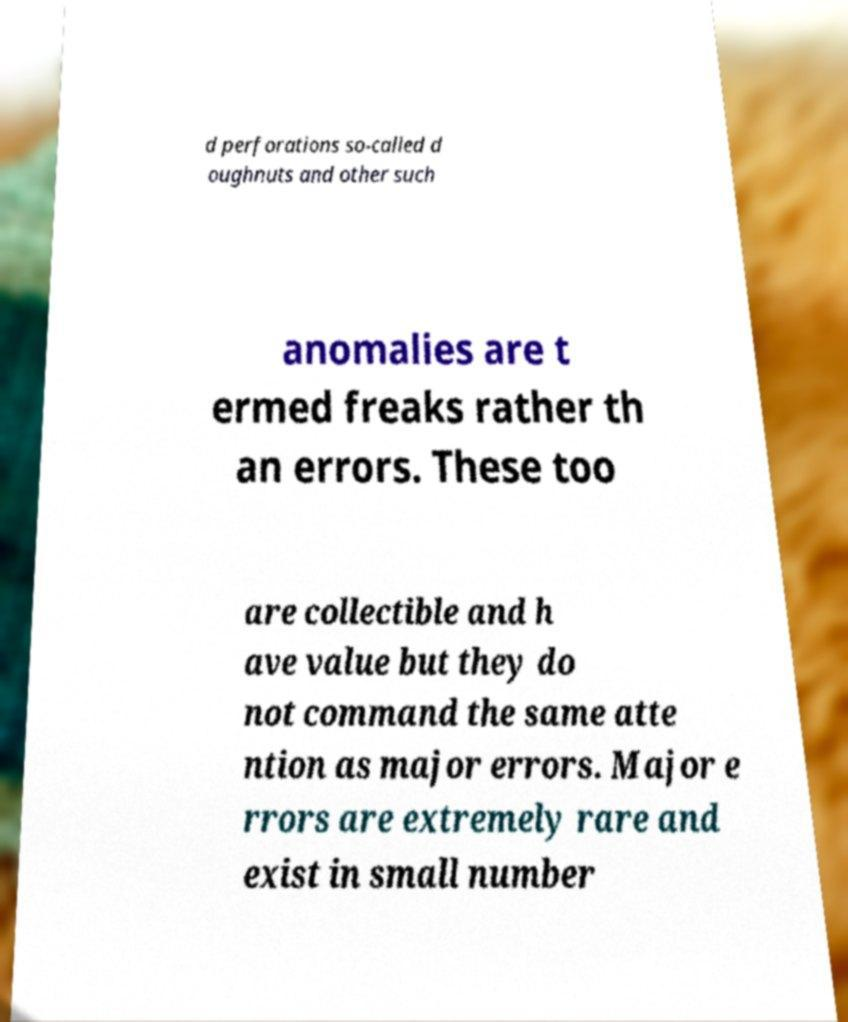Please identify and transcribe the text found in this image. d perforations so-called d oughnuts and other such anomalies are t ermed freaks rather th an errors. These too are collectible and h ave value but they do not command the same atte ntion as major errors. Major e rrors are extremely rare and exist in small number 